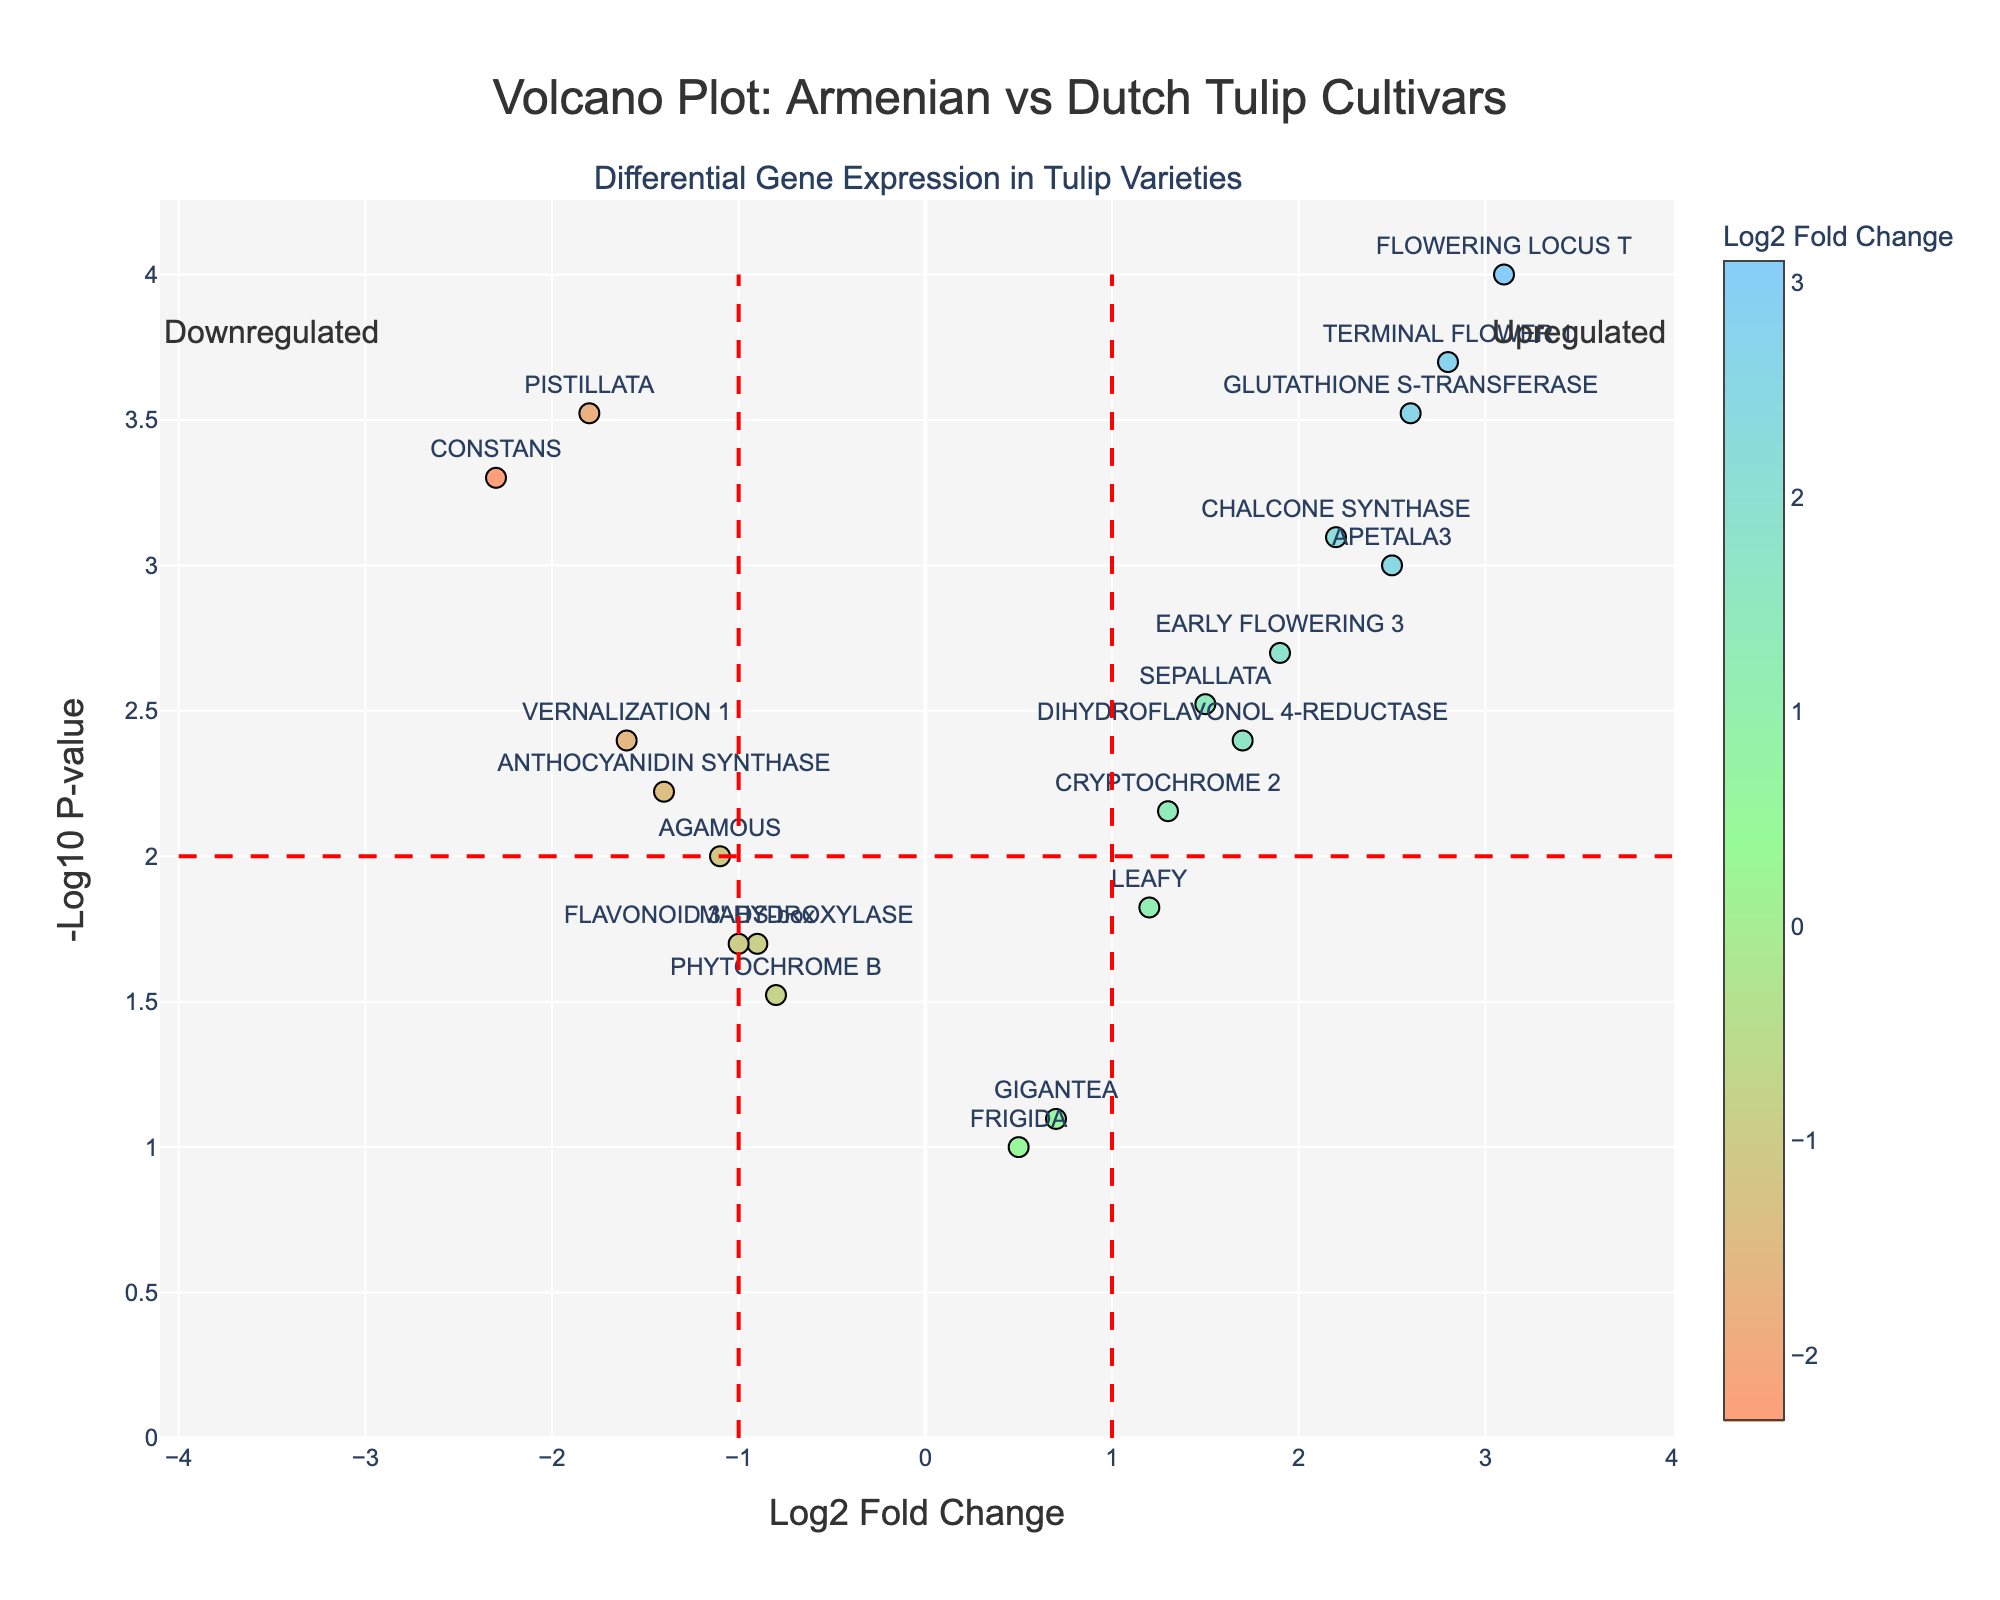What's the title of the figure? The title can be found at the top of the figure. It provides a quick context about the data being represented.
Answer: Volcano Plot: Armenian vs Dutch Tulip Cultivars What do the x and y axes represent? The x-axis represents the Log2 Fold Change, which shows the change in expression levels between the Armenian and Dutch tulip cultivars. The y-axis represents the -Log10 P-value, a measure of the statistical significance of those changes.
Answer: Log2 Fold Change and -Log10 P-value How many genes have a log2 fold change greater than 2? Count the data points to the right of the vertical line at Log2 Fold Change = 2. From quick observation of the points with labels, these include APETALA3, FLOWERING LOCUS T, TERMINAL FLOWER 1, CHALCONE SYNTHASE, and GLUTHATHIONE S-TRANSFERASE.
Answer: 5 Which gene is most significantly upregulated? The most significantly upregulated gene has the highest y-value (smallest p-value) and a positive x-value. FLOWERING LOCUS T is positioned at the top-right, representing the highest value on the y-axis with the positive log2 fold change.
Answer: FLOWERING LOCUS T Identify the gene with the largest absolute value of log2 fold change. Find the gene with the largest distance from zero on the x-axis, regardless of direction. CONSTANS has a log2 fold change of -2.3, which is the largest in magnitude.
Answer: CONSTANS What is the approximate -log10 p-value for the gene 'EARLY FLOWERING 3'? Locate the data point labeled EARLY FLOWERING 3 and read its y-axis value. The y-axis value for this gene is approximately 3.
Answer: 3 Which genes are downregulated and have a p-value less than 0.01? Look for genes with negative log2 fold change values to the left of the y-axis and with y-values greater than 2. These genes are PISTILLATA, CONSTANS, VERANILIZATION 1, and ANTHOCYANIDIN SYNTHASE.
Answer: PISTILLATA, CONSTANS, VERNALIZATION 1, ANTHOCYANIDIN SYNTHASE How many genes have a p-value of 0.02? Find points positioned at y=-log10(0.02) which is approximately 1.7. The genes with this p-value are MADS-box and FLAVONOID 3'-HYDROXYLASE.
Answer: 2 Which genes are neither significantly upregulated nor downregulated? Find genes near the center (close to 0 on the x-axis) and below the red horizontal line at y=2. These include GIGANTEA, PHYTOCHROME B, MADS-box, and FLAVONOID 3'-HYDROXYLASE.
Answer: GIGANTEA, PHYTOCHROME B, MADS-box, FLAVONOID 3'-HYDROXYLASE 